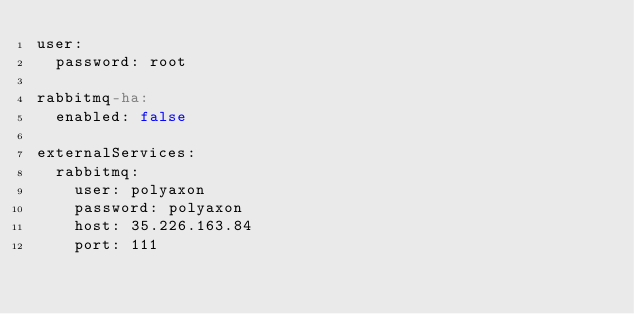Convert code to text. <code><loc_0><loc_0><loc_500><loc_500><_YAML_>user:
  password: root

rabbitmq-ha:
  enabled: false

externalServices:
  rabbitmq:
    user: polyaxon
    password: polyaxon
    host: 35.226.163.84
    port: 111
</code> 